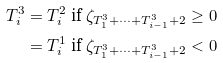<formula> <loc_0><loc_0><loc_500><loc_500>T ^ { 3 } _ { i } & = T ^ { 2 } _ { i } \ \text {if} \ \zeta _ { T ^ { 3 } _ { 1 } + \dots + T ^ { 3 } _ { i - 1 } + 2 } \geq 0 \\ & = T ^ { 1 } _ { i } \ \text {if} \ \zeta _ { T ^ { 3 } _ { 1 } + \dots + T ^ { 3 } _ { i - 1 } + 2 } < 0</formula> 